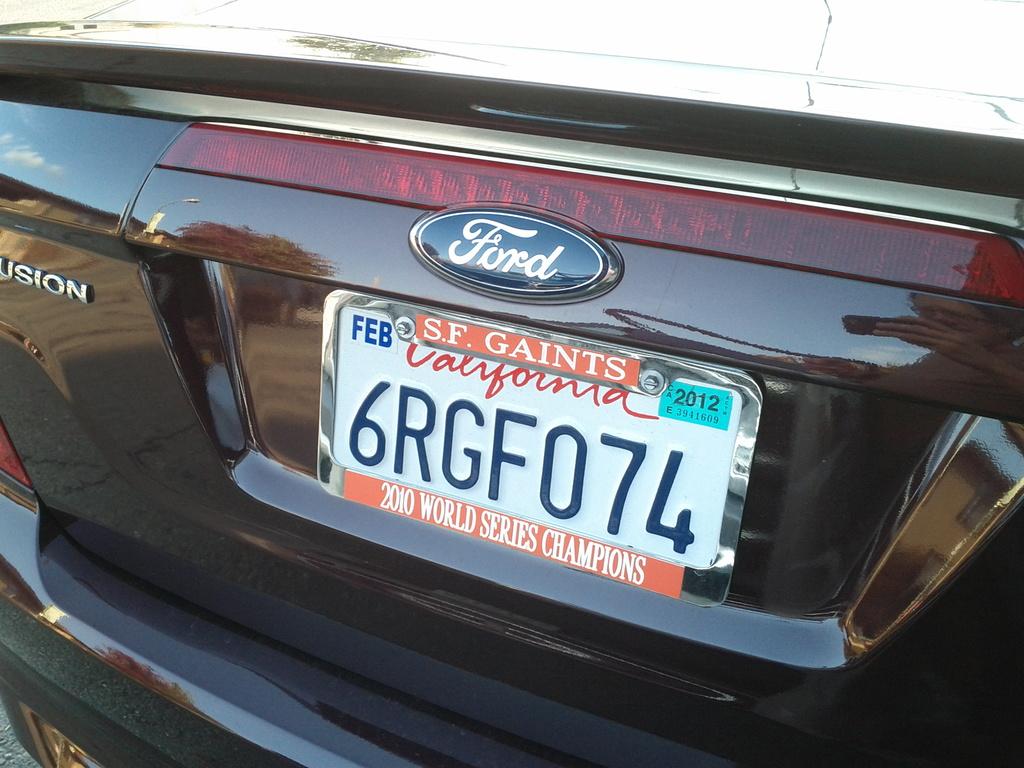What did the giants win in 2010?
Ensure brevity in your answer.  World series. Is this person a san fransisco gaints fan?
Ensure brevity in your answer.  Yes. 